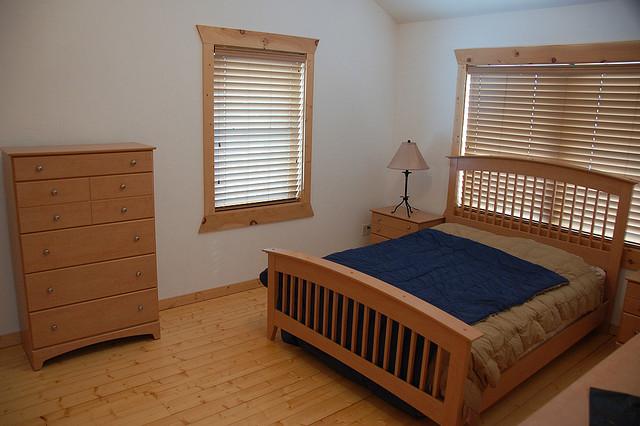Are there the blinds in the window?
Give a very brief answer. Yes. What type of room is this?
Short answer required. Bedroom. Is that a bunk bed?
Short answer required. No. What is the main piece of furniture in the picture?
Be succinct. Bed. What is the source of heat?
Answer briefly. Heater. What is on the bed?
Answer briefly. Blanket. Is the headboard padded?
Quick response, please. No. How many smaller boards is this bed's headboard made of?
Quick response, please. 30. How many windows are there?
Give a very brief answer. 2. 